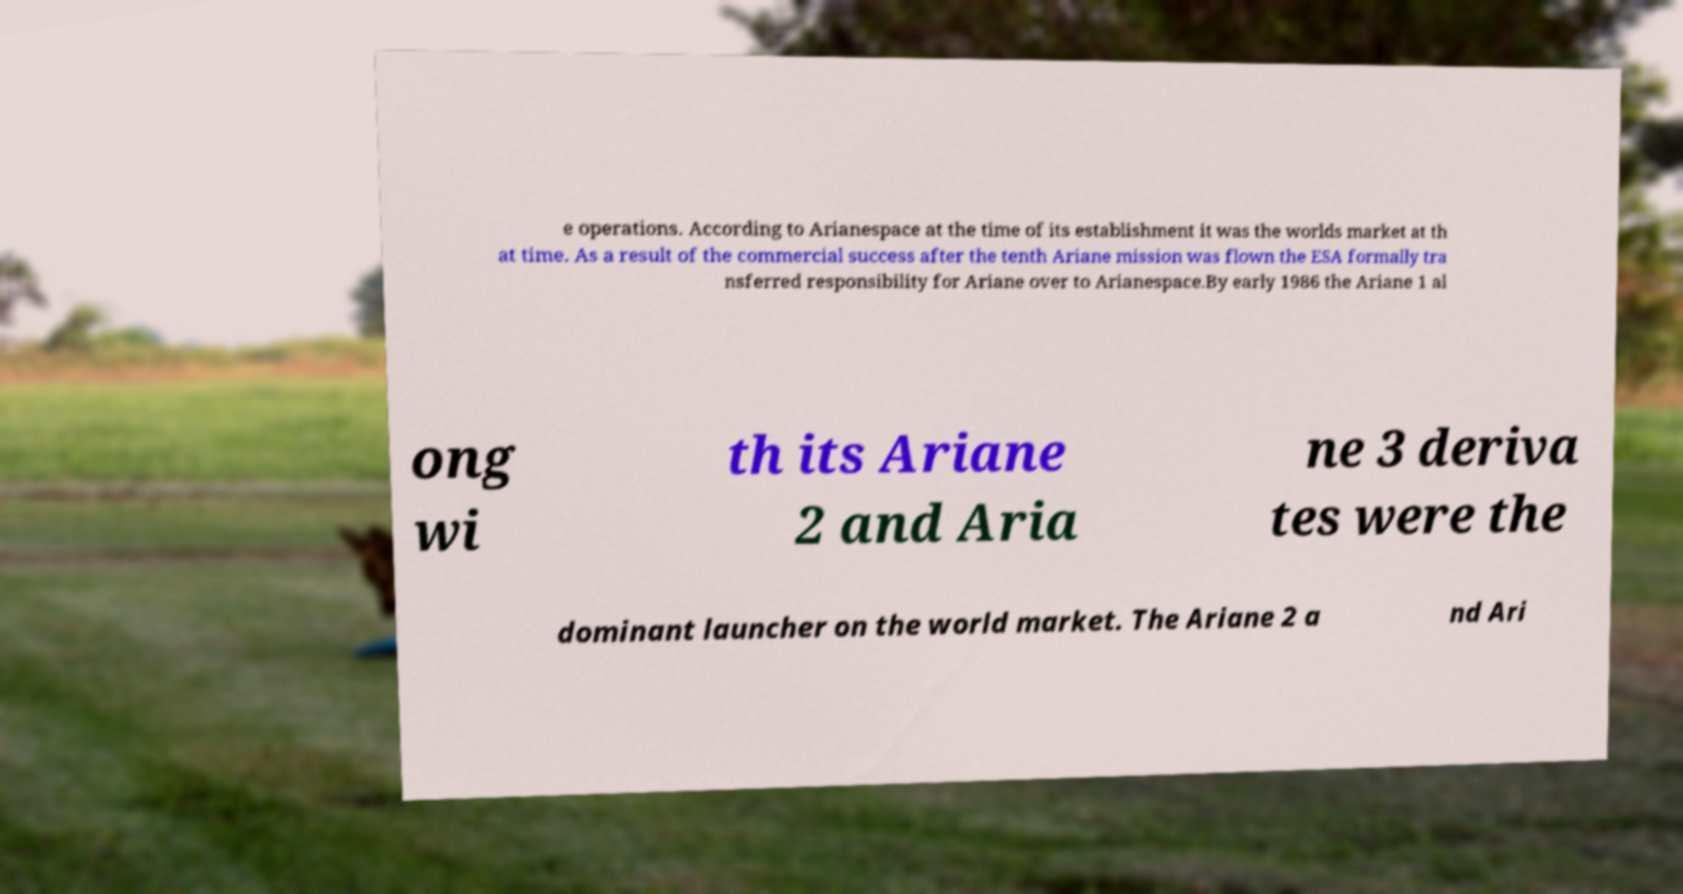I need the written content from this picture converted into text. Can you do that? e operations. According to Arianespace at the time of its establishment it was the worlds market at th at time. As a result of the commercial success after the tenth Ariane mission was flown the ESA formally tra nsferred responsibility for Ariane over to Arianespace.By early 1986 the Ariane 1 al ong wi th its Ariane 2 and Aria ne 3 deriva tes were the dominant launcher on the world market. The Ariane 2 a nd Ari 